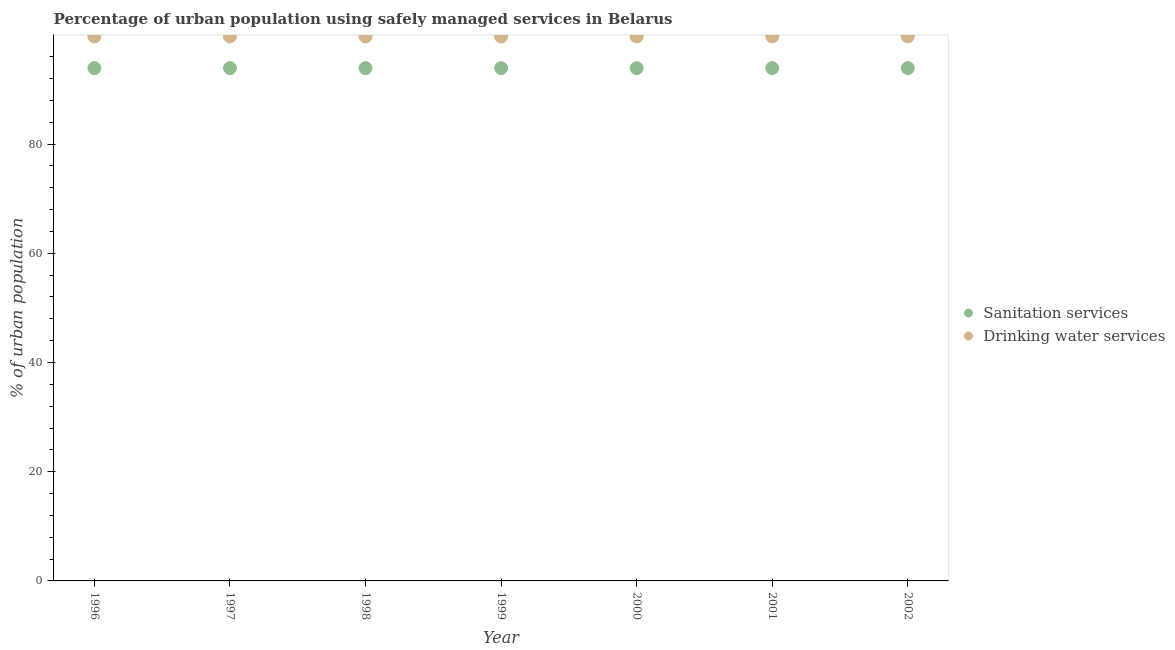How many different coloured dotlines are there?
Provide a short and direct response. 2. What is the percentage of urban population who used drinking water services in 1996?
Make the answer very short. 99.7. Across all years, what is the maximum percentage of urban population who used drinking water services?
Your answer should be very brief. 99.7. Across all years, what is the minimum percentage of urban population who used sanitation services?
Your answer should be compact. 93.9. In which year was the percentage of urban population who used sanitation services maximum?
Offer a terse response. 1996. In which year was the percentage of urban population who used sanitation services minimum?
Your answer should be very brief. 1996. What is the total percentage of urban population who used drinking water services in the graph?
Your response must be concise. 697.9. What is the difference between the percentage of urban population who used sanitation services in 1999 and the percentage of urban population who used drinking water services in 1996?
Offer a terse response. -5.8. What is the average percentage of urban population who used sanitation services per year?
Ensure brevity in your answer.  93.9. In the year 2000, what is the difference between the percentage of urban population who used drinking water services and percentage of urban population who used sanitation services?
Make the answer very short. 5.8. What is the ratio of the percentage of urban population who used sanitation services in 1997 to that in 2000?
Make the answer very short. 1. Is the percentage of urban population who used sanitation services in 1998 less than that in 2000?
Ensure brevity in your answer.  No. What is the difference between the highest and the lowest percentage of urban population who used drinking water services?
Make the answer very short. 0. In how many years, is the percentage of urban population who used drinking water services greater than the average percentage of urban population who used drinking water services taken over all years?
Make the answer very short. 0. Does the percentage of urban population who used sanitation services monotonically increase over the years?
Provide a short and direct response. No. Is the percentage of urban population who used drinking water services strictly less than the percentage of urban population who used sanitation services over the years?
Keep it short and to the point. No. What is the difference between two consecutive major ticks on the Y-axis?
Make the answer very short. 20. Are the values on the major ticks of Y-axis written in scientific E-notation?
Offer a very short reply. No. Does the graph contain grids?
Offer a very short reply. No. Where does the legend appear in the graph?
Your answer should be very brief. Center right. What is the title of the graph?
Make the answer very short. Percentage of urban population using safely managed services in Belarus. What is the label or title of the X-axis?
Your answer should be compact. Year. What is the label or title of the Y-axis?
Offer a terse response. % of urban population. What is the % of urban population in Sanitation services in 1996?
Keep it short and to the point. 93.9. What is the % of urban population in Drinking water services in 1996?
Keep it short and to the point. 99.7. What is the % of urban population of Sanitation services in 1997?
Provide a succinct answer. 93.9. What is the % of urban population in Drinking water services in 1997?
Give a very brief answer. 99.7. What is the % of urban population of Sanitation services in 1998?
Offer a terse response. 93.9. What is the % of urban population in Drinking water services in 1998?
Your answer should be very brief. 99.7. What is the % of urban population in Sanitation services in 1999?
Make the answer very short. 93.9. What is the % of urban population of Drinking water services in 1999?
Offer a terse response. 99.7. What is the % of urban population of Sanitation services in 2000?
Ensure brevity in your answer.  93.9. What is the % of urban population of Drinking water services in 2000?
Make the answer very short. 99.7. What is the % of urban population in Sanitation services in 2001?
Provide a short and direct response. 93.9. What is the % of urban population in Drinking water services in 2001?
Make the answer very short. 99.7. What is the % of urban population in Sanitation services in 2002?
Offer a very short reply. 93.9. What is the % of urban population in Drinking water services in 2002?
Offer a terse response. 99.7. Across all years, what is the maximum % of urban population of Sanitation services?
Provide a short and direct response. 93.9. Across all years, what is the maximum % of urban population in Drinking water services?
Keep it short and to the point. 99.7. Across all years, what is the minimum % of urban population of Sanitation services?
Provide a short and direct response. 93.9. Across all years, what is the minimum % of urban population of Drinking water services?
Provide a short and direct response. 99.7. What is the total % of urban population of Sanitation services in the graph?
Keep it short and to the point. 657.3. What is the total % of urban population in Drinking water services in the graph?
Ensure brevity in your answer.  697.9. What is the difference between the % of urban population in Sanitation services in 1996 and that in 1998?
Give a very brief answer. 0. What is the difference between the % of urban population of Drinking water services in 1996 and that in 1999?
Make the answer very short. 0. What is the difference between the % of urban population of Drinking water services in 1996 and that in 2001?
Offer a very short reply. 0. What is the difference between the % of urban population in Sanitation services in 1996 and that in 2002?
Offer a very short reply. 0. What is the difference between the % of urban population in Drinking water services in 1996 and that in 2002?
Your response must be concise. 0. What is the difference between the % of urban population of Sanitation services in 1997 and that in 1998?
Offer a terse response. 0. What is the difference between the % of urban population in Drinking water services in 1997 and that in 1998?
Provide a short and direct response. 0. What is the difference between the % of urban population of Sanitation services in 1997 and that in 1999?
Keep it short and to the point. 0. What is the difference between the % of urban population in Drinking water services in 1997 and that in 1999?
Offer a terse response. 0. What is the difference between the % of urban population in Drinking water services in 1997 and that in 2001?
Provide a short and direct response. 0. What is the difference between the % of urban population of Drinking water services in 1997 and that in 2002?
Make the answer very short. 0. What is the difference between the % of urban population in Drinking water services in 1998 and that in 1999?
Offer a terse response. 0. What is the difference between the % of urban population in Drinking water services in 1998 and that in 2000?
Keep it short and to the point. 0. What is the difference between the % of urban population of Drinking water services in 1998 and that in 2001?
Your response must be concise. 0. What is the difference between the % of urban population of Drinking water services in 1999 and that in 2000?
Give a very brief answer. 0. What is the difference between the % of urban population in Drinking water services in 1999 and that in 2001?
Your answer should be very brief. 0. What is the difference between the % of urban population of Drinking water services in 1999 and that in 2002?
Ensure brevity in your answer.  0. What is the difference between the % of urban population of Drinking water services in 2000 and that in 2002?
Your answer should be very brief. 0. What is the difference between the % of urban population of Sanitation services in 1996 and the % of urban population of Drinking water services in 1998?
Make the answer very short. -5.8. What is the difference between the % of urban population of Sanitation services in 1996 and the % of urban population of Drinking water services in 1999?
Make the answer very short. -5.8. What is the difference between the % of urban population of Sanitation services in 1996 and the % of urban population of Drinking water services in 2002?
Give a very brief answer. -5.8. What is the difference between the % of urban population of Sanitation services in 1997 and the % of urban population of Drinking water services in 1999?
Ensure brevity in your answer.  -5.8. What is the difference between the % of urban population in Sanitation services in 1997 and the % of urban population in Drinking water services in 2000?
Make the answer very short. -5.8. What is the difference between the % of urban population of Sanitation services in 1997 and the % of urban population of Drinking water services in 2002?
Your answer should be very brief. -5.8. What is the difference between the % of urban population in Sanitation services in 1998 and the % of urban population in Drinking water services in 2001?
Ensure brevity in your answer.  -5.8. What is the difference between the % of urban population in Sanitation services in 1999 and the % of urban population in Drinking water services in 2000?
Provide a short and direct response. -5.8. What is the difference between the % of urban population in Sanitation services in 2000 and the % of urban population in Drinking water services in 2002?
Offer a very short reply. -5.8. What is the difference between the % of urban population of Sanitation services in 2001 and the % of urban population of Drinking water services in 2002?
Make the answer very short. -5.8. What is the average % of urban population of Sanitation services per year?
Your answer should be compact. 93.9. What is the average % of urban population of Drinking water services per year?
Ensure brevity in your answer.  99.7. In the year 1996, what is the difference between the % of urban population in Sanitation services and % of urban population in Drinking water services?
Provide a succinct answer. -5.8. In the year 1998, what is the difference between the % of urban population in Sanitation services and % of urban population in Drinking water services?
Your response must be concise. -5.8. In the year 1999, what is the difference between the % of urban population of Sanitation services and % of urban population of Drinking water services?
Give a very brief answer. -5.8. In the year 2001, what is the difference between the % of urban population of Sanitation services and % of urban population of Drinking water services?
Make the answer very short. -5.8. In the year 2002, what is the difference between the % of urban population of Sanitation services and % of urban population of Drinking water services?
Provide a short and direct response. -5.8. What is the ratio of the % of urban population in Drinking water services in 1996 to that in 1999?
Your answer should be compact. 1. What is the ratio of the % of urban population of Sanitation services in 1996 to that in 2001?
Provide a short and direct response. 1. What is the ratio of the % of urban population in Drinking water services in 1996 to that in 2001?
Ensure brevity in your answer.  1. What is the ratio of the % of urban population in Sanitation services in 1996 to that in 2002?
Offer a very short reply. 1. What is the ratio of the % of urban population in Drinking water services in 1996 to that in 2002?
Offer a very short reply. 1. What is the ratio of the % of urban population of Sanitation services in 1997 to that in 1998?
Your answer should be very brief. 1. What is the ratio of the % of urban population of Drinking water services in 1997 to that in 1998?
Make the answer very short. 1. What is the ratio of the % of urban population of Sanitation services in 1997 to that in 1999?
Make the answer very short. 1. What is the ratio of the % of urban population in Sanitation services in 1997 to that in 2000?
Your answer should be very brief. 1. What is the ratio of the % of urban population of Drinking water services in 1997 to that in 2000?
Your answer should be compact. 1. What is the ratio of the % of urban population of Sanitation services in 1997 to that in 2002?
Offer a very short reply. 1. What is the ratio of the % of urban population of Drinking water services in 1998 to that in 1999?
Offer a terse response. 1. What is the ratio of the % of urban population in Sanitation services in 1998 to that in 2000?
Provide a short and direct response. 1. What is the ratio of the % of urban population in Drinking water services in 1998 to that in 2000?
Offer a terse response. 1. What is the ratio of the % of urban population of Sanitation services in 1998 to that in 2001?
Make the answer very short. 1. What is the ratio of the % of urban population in Drinking water services in 1998 to that in 2002?
Ensure brevity in your answer.  1. What is the ratio of the % of urban population in Sanitation services in 1999 to that in 2000?
Give a very brief answer. 1. What is the ratio of the % of urban population in Sanitation services in 1999 to that in 2002?
Your answer should be very brief. 1. What is the ratio of the % of urban population of Sanitation services in 2000 to that in 2001?
Your answer should be very brief. 1. What is the ratio of the % of urban population in Drinking water services in 2000 to that in 2001?
Provide a short and direct response. 1. What is the ratio of the % of urban population of Sanitation services in 2000 to that in 2002?
Provide a short and direct response. 1. What is the ratio of the % of urban population in Drinking water services in 2000 to that in 2002?
Your answer should be very brief. 1. What is the ratio of the % of urban population in Drinking water services in 2001 to that in 2002?
Offer a terse response. 1. What is the difference between the highest and the second highest % of urban population in Sanitation services?
Provide a succinct answer. 0. What is the difference between the highest and the lowest % of urban population of Sanitation services?
Give a very brief answer. 0. 